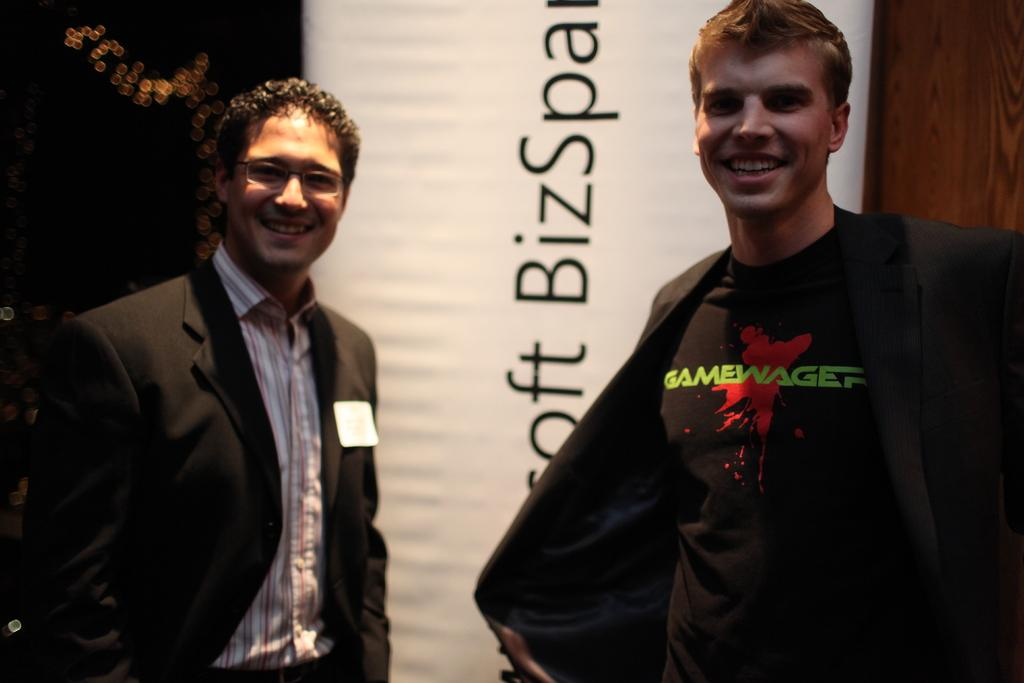How many people are in the image? There are two people in the image. What are the people doing in the image? The people are standing and smiling. What are the people wearing in the image? The people are wearing black coats. What can be seen in the background of the image? There is a white banner visible in the image. What is written on the banner? There is text written on the banner. How does the army use the cushion in the image? There is no army or cushion present in the image. 